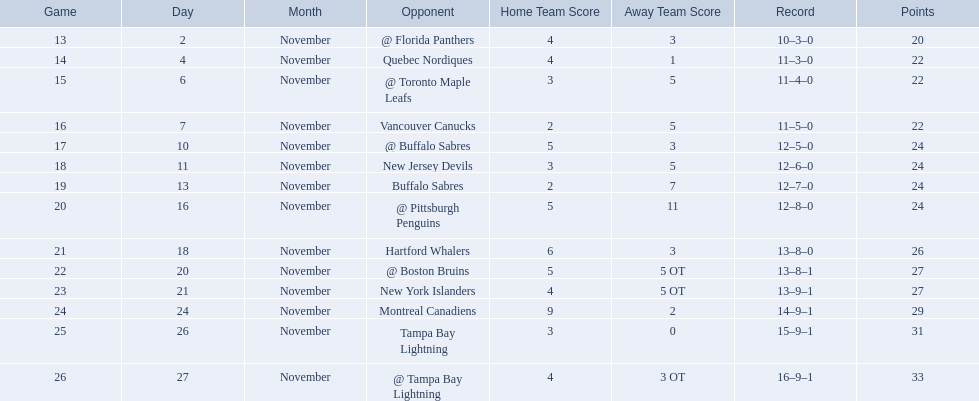Who are all of the teams? @ Florida Panthers, Quebec Nordiques, @ Toronto Maple Leafs, Vancouver Canucks, @ Buffalo Sabres, New Jersey Devils, Buffalo Sabres, @ Pittsburgh Penguins, Hartford Whalers, @ Boston Bruins, New York Islanders, Montreal Canadiens, Tampa Bay Lightning. What games finished in overtime? 22, 23, 26. In game number 23, who did they face? New York Islanders. 